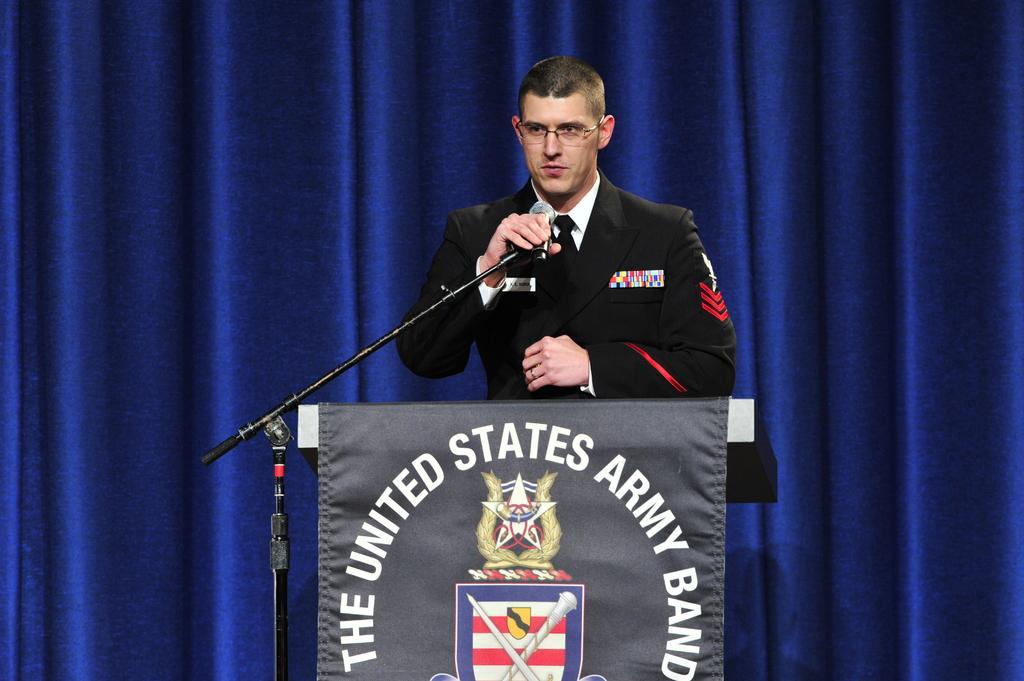Can you describe this image briefly? In the center of the image there is a person standing near a podium talking in a mic. In the background of the image there is a blue color cloth. 